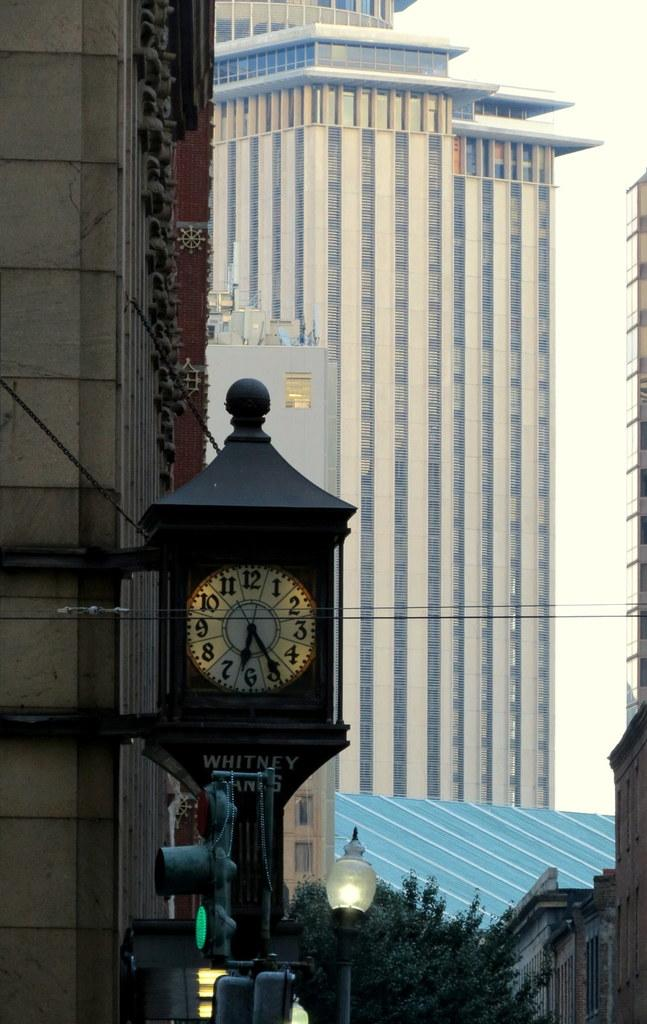Provide a one-sentence caption for the provided image. An old fashioned clock set at twenty five past six. 